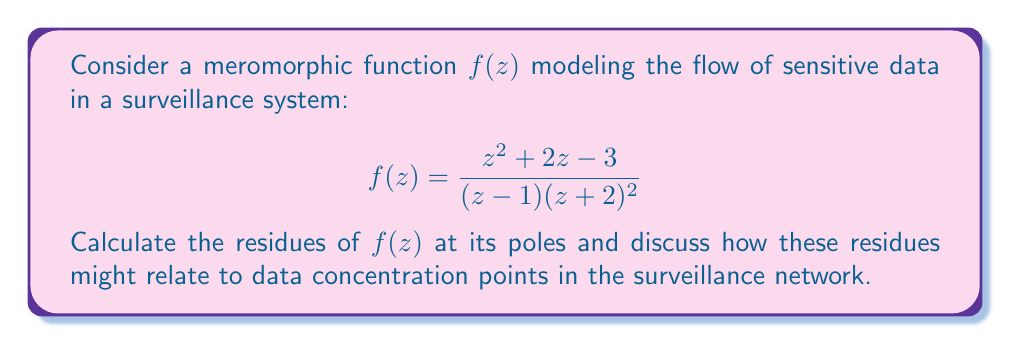What is the answer to this math problem? To calculate the residues of $f(z)$, we need to identify its poles and determine their order:

1. $z = 1$ is a simple pole (order 1)
2. $z = -2$ is a double pole (order 2)

For the simple pole at $z = 1$:
The residue can be calculated using the formula:
$$\text{Res}(f, 1) = \lim_{z \to 1} (z-1)f(z)$$

$$\begin{aligned}
\text{Res}(f, 1) &= \lim_{z \to 1} (z-1)\frac{z^2 + 2z - 3}{(z-1)(z+2)^2} \\
&= \lim_{z \to 1} \frac{z^2 + 2z - 3}{(z+2)^2} \\
&= \frac{1^2 + 2(1) - 3}{(1+2)^2} = \frac{0}{9} = 0
\end{aligned}$$

For the double pole at $z = -2$:
We use the formula for the residue of a double pole:
$$\text{Res}(f, -2) = \lim_{z \to -2} \frac{d}{dz}[(z+2)^2f(z)]$$

$$\begin{aligned}
\text{Res}(f, -2) &= \lim_{z \to -2} \frac{d}{dz}\left[(z+2)^2 \cdot \frac{z^2 + 2z - 3}{(z-1)(z+2)^2}\right] \\
&= \lim_{z \to -2} \frac{d}{dz}\left[\frac{z^2 + 2z - 3}{z-1}\right] \\
&= \lim_{z \to -2} \frac{(z-1)(2z+2) - (z^2 + 2z - 3)}{(z-1)^2} \\
&= \frac{(-2-1)(2(-2)+2) - ((-2)^2 + 2(-2) - 3)}{(-2-1)^2} \\
&= \frac{(-3)(-2) - (4 - 4 - 3)}{9} = \frac{6 - (-3)}{9} = 1
\end{aligned}$$

In the context of data flow in surveillance systems:
1. The residue at $z = 1$ being 0 might indicate a point where data flows in and out equally, not accumulating.
2. The non-zero residue at $z = -2$ could represent a significant data concentration point, possibly a central hub or storage location in the surveillance network.

These mathematical results could prompt ethical considerations about data accumulation and potential vulnerabilities in the system.
Answer: The residues of $f(z)$ are:
$$\text{Res}(f, 1) = 0$$
$$\text{Res}(f, -2) = 1$$ 